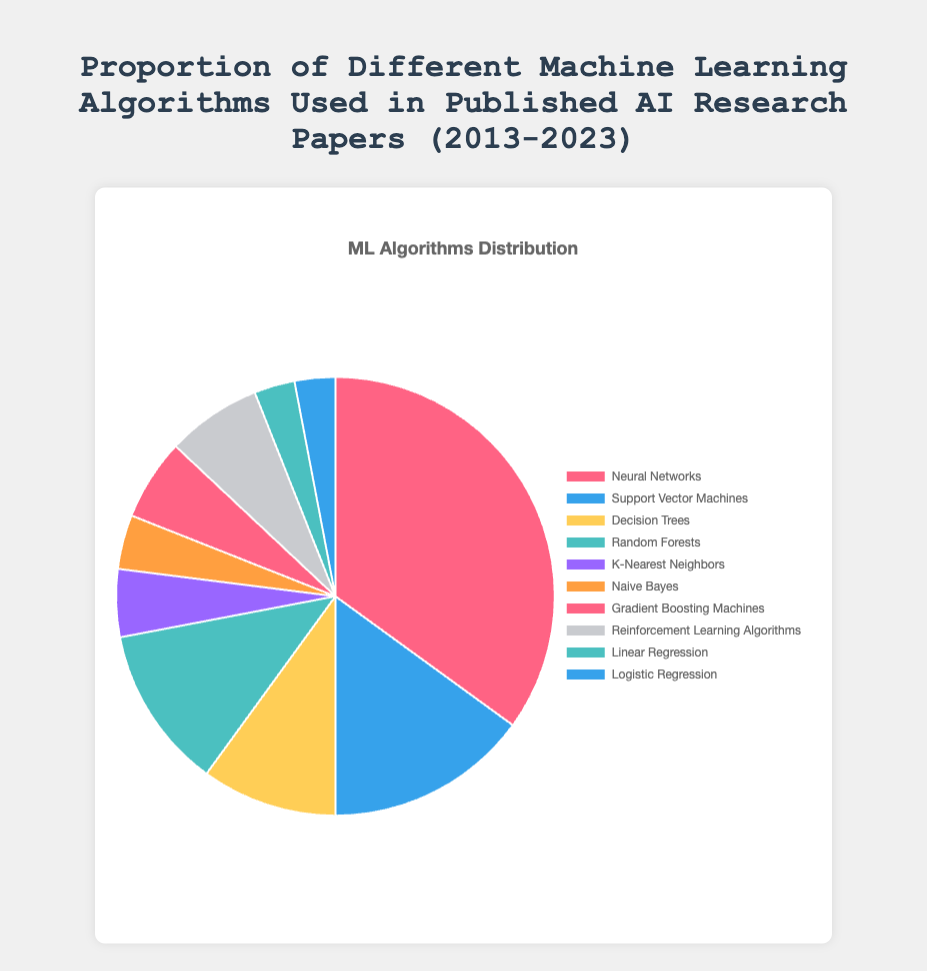What is the proportion of research papers that use Neural Networks as a machine learning algorithm? Neural Networks have a proportion of 35% in the pie chart. This can be directly read from the chart's legend or segment label.
Answer: 35% How does the proportion of Decision Trees compare to Reinforcement Learning Algorithms? Decision Trees have a proportion of 10%, while Reinforcement Learning Algorithms have a proportion of 7%. So, Decision Trees are more commonly used by 3%.
Answer: Decision Trees are more common by 3% Which machine learning algorithm is used least frequently? The algorithms with the smallest portions are Linear Regression and Logistic Regression, each with a proportion of 3%.
Answer: Linear Regression and Logistic Regression What is the total proportion of usage for Support Vector Machines, Random Forests, and Naive Bayes combined? Support Vector Machines have a proportion of 15%, Random Forests have 12%, and Naive Bayes have 4%. Adding these gives 15% + 12% + 4% = 31%.
Answer: 31% How much more frequently is Gradient Boosting Machines used compared to K-Nearest Neighbors? Gradient Boosting Machines have a proportion of 6%, and K-Nearest Neighbors have 5%. The difference is 6% - 5% = 1%.
Answer: 1% more Which algorithm is used more frequently, Random Forests or Gradient Boosting Machines, and by how much? Random Forests are used 12% of the time, and Gradient Boosting Machines are used 6%. Thus, Random Forests are used more frequently by 12% - 6% = 6%.
Answer: Random Forests by 6% What is the sum of the proportions of the three least frequently used algorithms? The three least frequently used algorithms are Naive Bayes (4%), Linear Regression (3%), and Logistic Regression (3%). Their combined proportion is 4% + 3% + 3% = 10%.
Answer: 10% Which algorithm, represented by the color red, has what proportion on the pie chart? Neural Networks are represented by the color red and they have a proportion of 35% on the pie chart.
Answer: 35% What is the difference in proportion between the most frequently used algorithm and the least frequently used algorithms combined? The most frequently used algorithm (Neural Networks) has 35%. The least frequently used algorithms (Linear Regression and Logistic Regression) combined have 3% + 3% = 6%. The difference is 35% - 6% = 29%.
Answer: 29% If you sum the proportion of all algorithms except for Neural Networks, what is that value? Excluding Neural Networks (35%), add the remaining proportions: 15% (SVM) + 10% (Decision Trees) + 12% (Random Forests) + 5% (KNN) + 4% (Naive Bayes) + 6% (GBM) + 7% (Reinforcement Learning) + 3% (Linear Regression) + 3% (Logistic Regression) = 65%.
Answer: 65% 